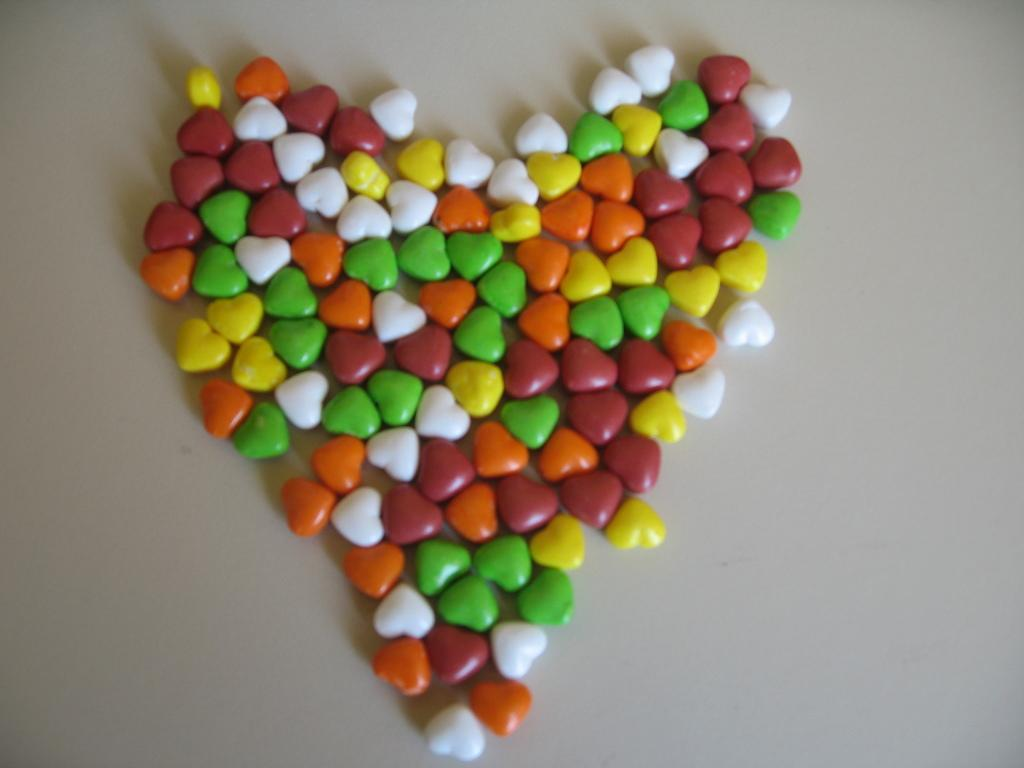What type of candy is present in the image? There are chocolate gems in the image. How many brothers are wearing masks in the image? There are no brothers or masks present in the image; it only features chocolate gems. 